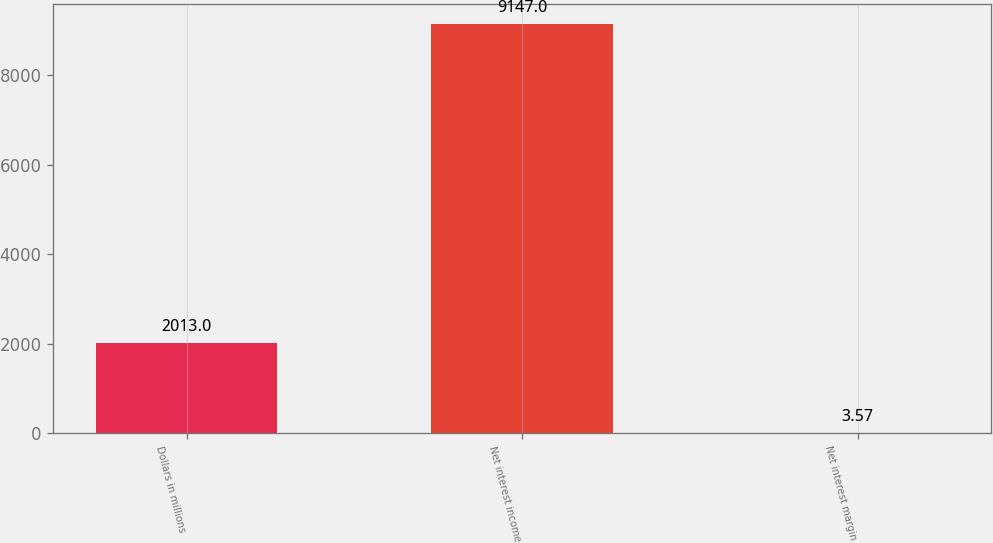Convert chart to OTSL. <chart><loc_0><loc_0><loc_500><loc_500><bar_chart><fcel>Dollars in millions<fcel>Net interest income<fcel>Net interest margin<nl><fcel>2013<fcel>9147<fcel>3.57<nl></chart> 